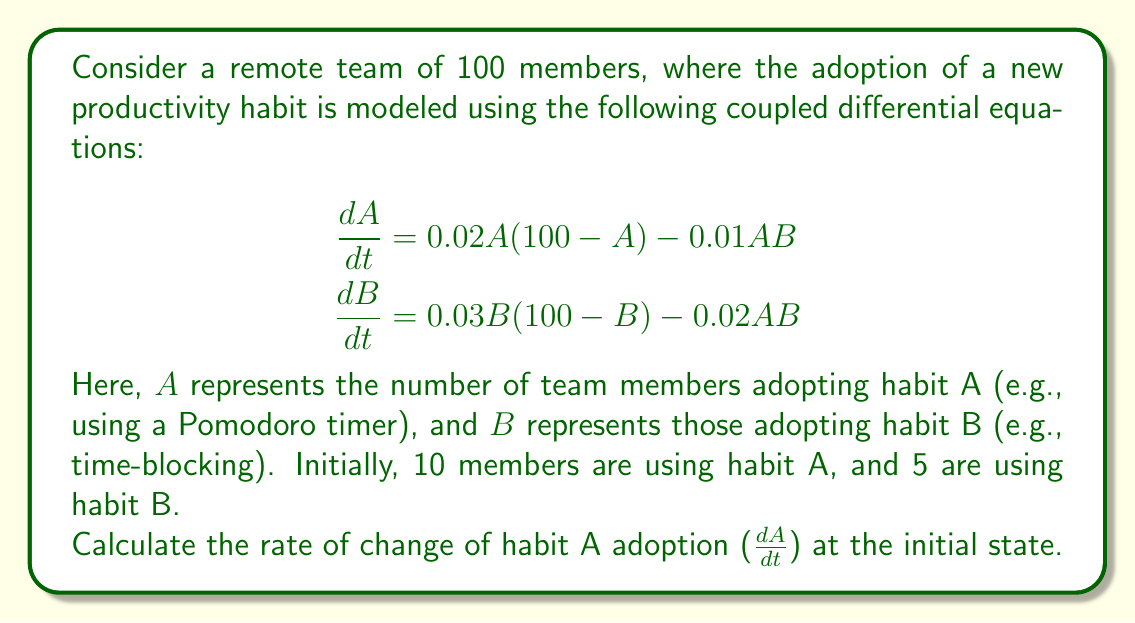Help me with this question. To solve this problem, we'll follow these steps:

1) We're given the differential equation for $\frac{dA}{dt}$:

   $$\frac{dA}{dt} = 0.02A(100-A) - 0.01AB$$

2) We know the initial conditions:
   - Total team members = 100
   - Initial A adopters = 10
   - Initial B adopters = 5

3) Let's substitute these values into the equation:

   $$\frac{dA}{dt} = 0.02(10)(100-10) - 0.01(10)(5)$$

4) Let's calculate each term:
   - $0.02(10)(100-10) = 0.02(10)(90) = 18$
   - $0.01(10)(5) = 0.5$

5) Now, we can complete the calculation:

   $$\frac{dA}{dt} = 18 - 0.5 = 17.5$$

Therefore, at the initial state, the rate of change of habit A adoption is 17.5 members per unit time.
Answer: 17.5 members/time unit 